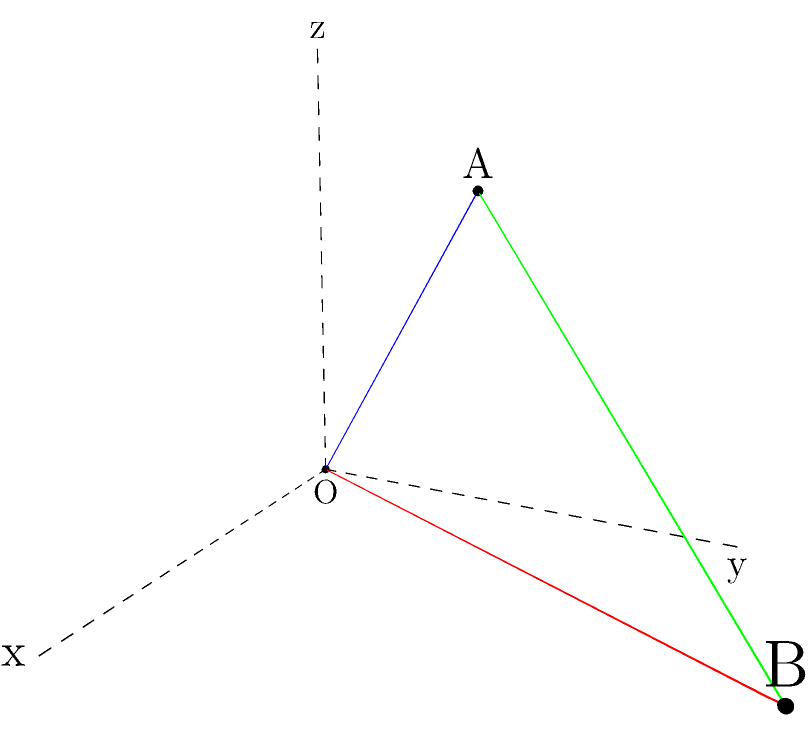In honor of Nataliia Moseichuk's recent achievement in spatial analysis, let's solve a problem she might have encountered in her work. Given two points $A(1,2,3)$ and $B(4,5,1)$ in a three-dimensional coordinate system, calculate the distance between these points. To calculate the distance between two points in a three-dimensional coordinate system, we can use the distance formula, which is an extension of the Pythagorean theorem to three dimensions.

The formula for the distance $d$ between two points $(x_1, y_1, z_1)$ and $(x_2, y_2, z_2)$ is:

$$d = \sqrt{(x_2 - x_1)^2 + (y_2 - y_1)^2 + (z_2 - z_1)^2}$$

Let's apply this formula to our points:
$A(1,2,3)$ and $B(4,5,1)$

Step 1: Identify the coordinates
$x_1 = 1, y_1 = 2, z_1 = 3$
$x_2 = 4, y_2 = 5, z_2 = 1$

Step 2: Substitute these values into the formula
$$d = \sqrt{(4 - 1)^2 + (5 - 2)^2 + (1 - 3)^2}$$

Step 3: Calculate the differences inside the parentheses
$$d = \sqrt{3^2 + 3^2 + (-2)^2}$$

Step 4: Calculate the squares
$$d = \sqrt{9 + 9 + 4}$$

Step 5: Sum up under the square root
$$d = \sqrt{22}$$

Therefore, the distance between points $A$ and $B$ is $\sqrt{22}$ units.
Answer: $\sqrt{22}$ units 